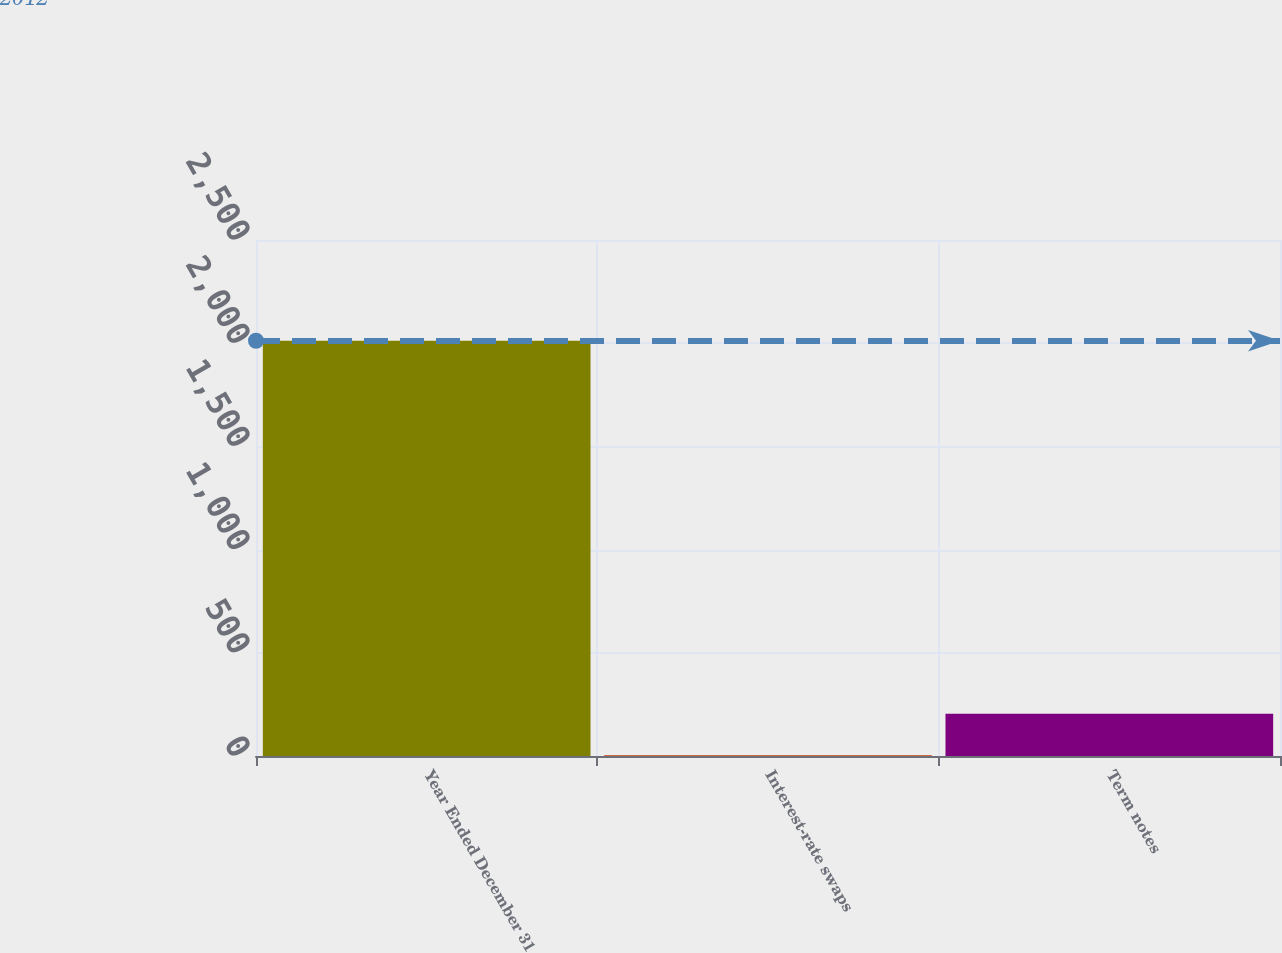Convert chart. <chart><loc_0><loc_0><loc_500><loc_500><bar_chart><fcel>Year Ended December 31<fcel>Interest-rate swaps<fcel>Term notes<nl><fcel>2012<fcel>3.8<fcel>204.62<nl></chart> 